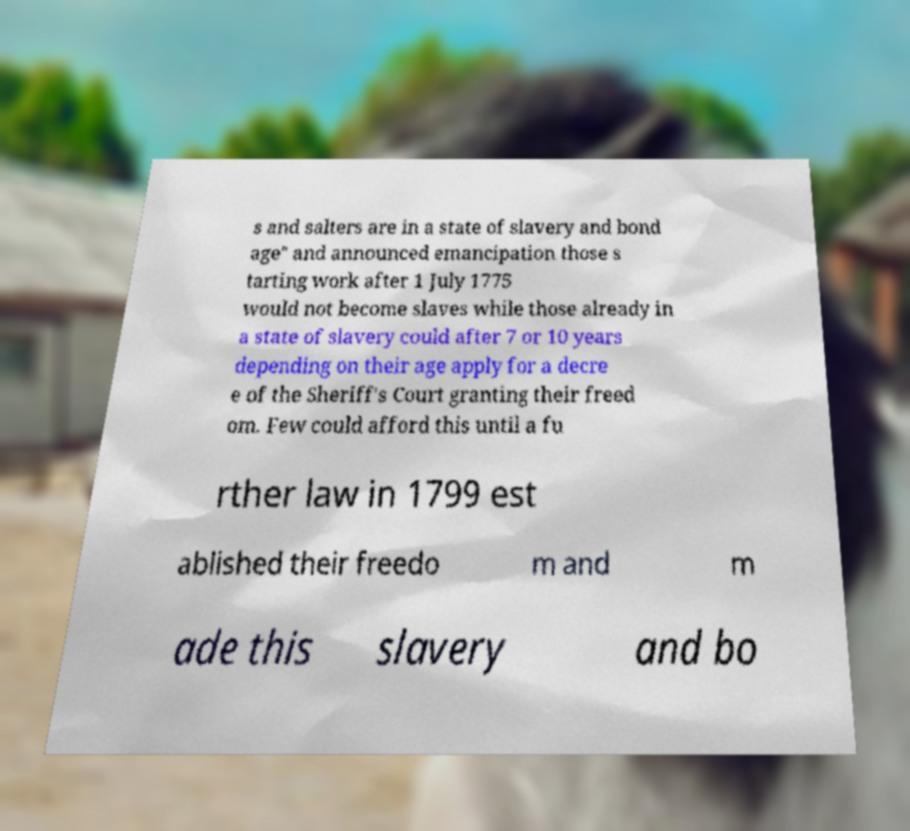Could you assist in decoding the text presented in this image and type it out clearly? s and salters are in a state of slavery and bond age" and announced emancipation those s tarting work after 1 July 1775 would not become slaves while those already in a state of slavery could after 7 or 10 years depending on their age apply for a decre e of the Sheriff's Court granting their freed om. Few could afford this until a fu rther law in 1799 est ablished their freedo m and m ade this slavery and bo 